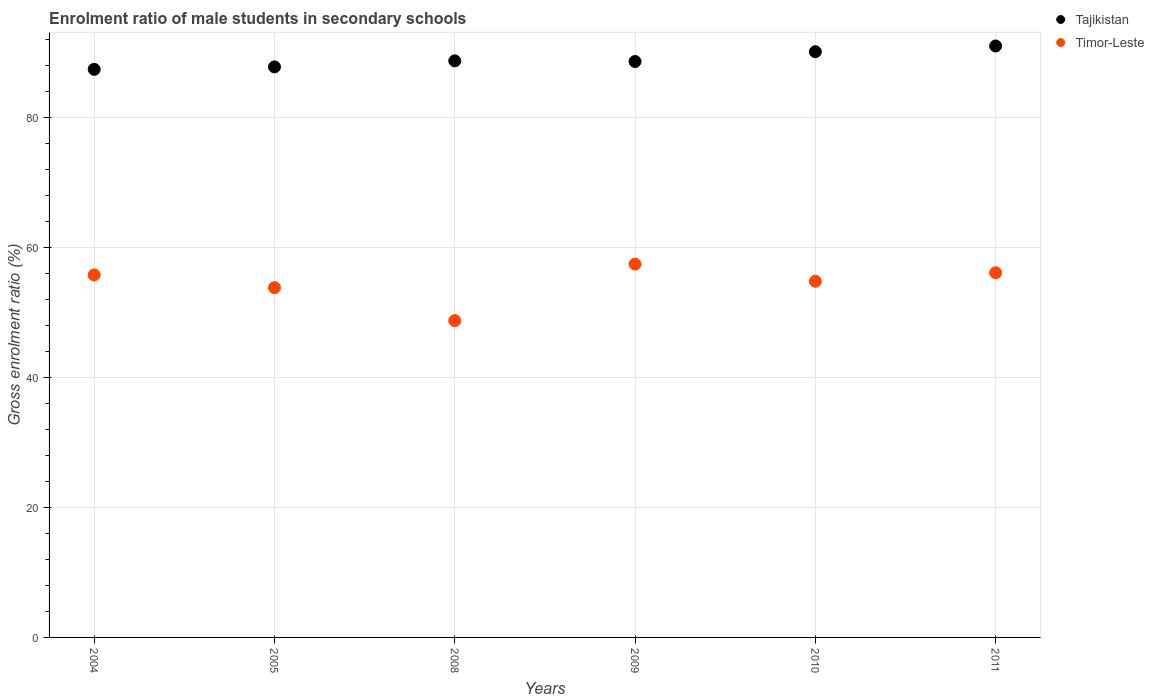What is the enrolment ratio of male students in secondary schools in Tajikistan in 2005?
Provide a succinct answer. 87.74. Across all years, what is the maximum enrolment ratio of male students in secondary schools in Tajikistan?
Offer a terse response. 90.96. Across all years, what is the minimum enrolment ratio of male students in secondary schools in Tajikistan?
Make the answer very short. 87.37. What is the total enrolment ratio of male students in secondary schools in Timor-Leste in the graph?
Give a very brief answer. 326.54. What is the difference between the enrolment ratio of male students in secondary schools in Timor-Leste in 2005 and that in 2009?
Ensure brevity in your answer.  -3.62. What is the difference between the enrolment ratio of male students in secondary schools in Timor-Leste in 2004 and the enrolment ratio of male students in secondary schools in Tajikistan in 2010?
Your answer should be compact. -34.32. What is the average enrolment ratio of male students in secondary schools in Timor-Leste per year?
Provide a succinct answer. 54.42. In the year 2009, what is the difference between the enrolment ratio of male students in secondary schools in Timor-Leste and enrolment ratio of male students in secondary schools in Tajikistan?
Offer a terse response. -31.16. In how many years, is the enrolment ratio of male students in secondary schools in Timor-Leste greater than 84 %?
Give a very brief answer. 0. What is the ratio of the enrolment ratio of male students in secondary schools in Tajikistan in 2005 to that in 2011?
Your answer should be compact. 0.96. What is the difference between the highest and the second highest enrolment ratio of male students in secondary schools in Timor-Leste?
Offer a terse response. 1.33. What is the difference between the highest and the lowest enrolment ratio of male students in secondary schools in Timor-Leste?
Give a very brief answer. 8.69. Is the sum of the enrolment ratio of male students in secondary schools in Tajikistan in 2010 and 2011 greater than the maximum enrolment ratio of male students in secondary schools in Timor-Leste across all years?
Offer a terse response. Yes. Is the enrolment ratio of male students in secondary schools in Tajikistan strictly less than the enrolment ratio of male students in secondary schools in Timor-Leste over the years?
Give a very brief answer. No. How many years are there in the graph?
Make the answer very short. 6. What is the difference between two consecutive major ticks on the Y-axis?
Your response must be concise. 20. Does the graph contain grids?
Offer a terse response. Yes. Where does the legend appear in the graph?
Your response must be concise. Top right. How many legend labels are there?
Offer a terse response. 2. How are the legend labels stacked?
Provide a short and direct response. Vertical. What is the title of the graph?
Make the answer very short. Enrolment ratio of male students in secondary schools. What is the Gross enrolment ratio (%) in Tajikistan in 2004?
Ensure brevity in your answer.  87.37. What is the Gross enrolment ratio (%) of Timor-Leste in 2004?
Give a very brief answer. 55.75. What is the Gross enrolment ratio (%) of Tajikistan in 2005?
Offer a terse response. 87.74. What is the Gross enrolment ratio (%) in Timor-Leste in 2005?
Ensure brevity in your answer.  53.79. What is the Gross enrolment ratio (%) in Tajikistan in 2008?
Provide a short and direct response. 88.67. What is the Gross enrolment ratio (%) in Timor-Leste in 2008?
Your response must be concise. 48.73. What is the Gross enrolment ratio (%) in Tajikistan in 2009?
Your answer should be compact. 88.57. What is the Gross enrolment ratio (%) in Timor-Leste in 2009?
Make the answer very short. 57.41. What is the Gross enrolment ratio (%) in Tajikistan in 2010?
Provide a succinct answer. 90.08. What is the Gross enrolment ratio (%) in Timor-Leste in 2010?
Offer a terse response. 54.77. What is the Gross enrolment ratio (%) of Tajikistan in 2011?
Your answer should be compact. 90.96. What is the Gross enrolment ratio (%) in Timor-Leste in 2011?
Your answer should be compact. 56.08. Across all years, what is the maximum Gross enrolment ratio (%) of Tajikistan?
Provide a succinct answer. 90.96. Across all years, what is the maximum Gross enrolment ratio (%) of Timor-Leste?
Your answer should be very brief. 57.41. Across all years, what is the minimum Gross enrolment ratio (%) of Tajikistan?
Your answer should be compact. 87.37. Across all years, what is the minimum Gross enrolment ratio (%) of Timor-Leste?
Ensure brevity in your answer.  48.73. What is the total Gross enrolment ratio (%) of Tajikistan in the graph?
Your answer should be very brief. 533.39. What is the total Gross enrolment ratio (%) in Timor-Leste in the graph?
Your response must be concise. 326.54. What is the difference between the Gross enrolment ratio (%) in Tajikistan in 2004 and that in 2005?
Make the answer very short. -0.38. What is the difference between the Gross enrolment ratio (%) of Timor-Leste in 2004 and that in 2005?
Your answer should be compact. 1.96. What is the difference between the Gross enrolment ratio (%) of Tajikistan in 2004 and that in 2008?
Give a very brief answer. -1.3. What is the difference between the Gross enrolment ratio (%) in Timor-Leste in 2004 and that in 2008?
Offer a terse response. 7.03. What is the difference between the Gross enrolment ratio (%) of Tajikistan in 2004 and that in 2009?
Offer a terse response. -1.2. What is the difference between the Gross enrolment ratio (%) in Timor-Leste in 2004 and that in 2009?
Offer a terse response. -1.66. What is the difference between the Gross enrolment ratio (%) in Tajikistan in 2004 and that in 2010?
Your response must be concise. -2.71. What is the difference between the Gross enrolment ratio (%) in Timor-Leste in 2004 and that in 2010?
Your answer should be very brief. 0.98. What is the difference between the Gross enrolment ratio (%) of Tajikistan in 2004 and that in 2011?
Provide a short and direct response. -3.59. What is the difference between the Gross enrolment ratio (%) in Timor-Leste in 2004 and that in 2011?
Offer a very short reply. -0.33. What is the difference between the Gross enrolment ratio (%) in Tajikistan in 2005 and that in 2008?
Give a very brief answer. -0.93. What is the difference between the Gross enrolment ratio (%) in Timor-Leste in 2005 and that in 2008?
Your response must be concise. 5.07. What is the difference between the Gross enrolment ratio (%) of Tajikistan in 2005 and that in 2009?
Provide a succinct answer. -0.83. What is the difference between the Gross enrolment ratio (%) of Timor-Leste in 2005 and that in 2009?
Ensure brevity in your answer.  -3.62. What is the difference between the Gross enrolment ratio (%) in Tajikistan in 2005 and that in 2010?
Provide a short and direct response. -2.34. What is the difference between the Gross enrolment ratio (%) of Timor-Leste in 2005 and that in 2010?
Keep it short and to the point. -0.98. What is the difference between the Gross enrolment ratio (%) of Tajikistan in 2005 and that in 2011?
Provide a short and direct response. -3.22. What is the difference between the Gross enrolment ratio (%) in Timor-Leste in 2005 and that in 2011?
Offer a terse response. -2.29. What is the difference between the Gross enrolment ratio (%) in Tajikistan in 2008 and that in 2009?
Ensure brevity in your answer.  0.1. What is the difference between the Gross enrolment ratio (%) in Timor-Leste in 2008 and that in 2009?
Your answer should be compact. -8.69. What is the difference between the Gross enrolment ratio (%) of Tajikistan in 2008 and that in 2010?
Offer a terse response. -1.41. What is the difference between the Gross enrolment ratio (%) of Timor-Leste in 2008 and that in 2010?
Keep it short and to the point. -6.05. What is the difference between the Gross enrolment ratio (%) in Tajikistan in 2008 and that in 2011?
Your answer should be very brief. -2.29. What is the difference between the Gross enrolment ratio (%) in Timor-Leste in 2008 and that in 2011?
Your response must be concise. -7.36. What is the difference between the Gross enrolment ratio (%) in Tajikistan in 2009 and that in 2010?
Your answer should be very brief. -1.51. What is the difference between the Gross enrolment ratio (%) in Timor-Leste in 2009 and that in 2010?
Your answer should be very brief. 2.64. What is the difference between the Gross enrolment ratio (%) in Tajikistan in 2009 and that in 2011?
Your answer should be compact. -2.39. What is the difference between the Gross enrolment ratio (%) of Timor-Leste in 2009 and that in 2011?
Offer a terse response. 1.33. What is the difference between the Gross enrolment ratio (%) in Tajikistan in 2010 and that in 2011?
Ensure brevity in your answer.  -0.88. What is the difference between the Gross enrolment ratio (%) in Timor-Leste in 2010 and that in 2011?
Provide a succinct answer. -1.31. What is the difference between the Gross enrolment ratio (%) in Tajikistan in 2004 and the Gross enrolment ratio (%) in Timor-Leste in 2005?
Make the answer very short. 33.58. What is the difference between the Gross enrolment ratio (%) of Tajikistan in 2004 and the Gross enrolment ratio (%) of Timor-Leste in 2008?
Give a very brief answer. 38.64. What is the difference between the Gross enrolment ratio (%) in Tajikistan in 2004 and the Gross enrolment ratio (%) in Timor-Leste in 2009?
Your response must be concise. 29.95. What is the difference between the Gross enrolment ratio (%) of Tajikistan in 2004 and the Gross enrolment ratio (%) of Timor-Leste in 2010?
Your answer should be very brief. 32.59. What is the difference between the Gross enrolment ratio (%) in Tajikistan in 2004 and the Gross enrolment ratio (%) in Timor-Leste in 2011?
Provide a short and direct response. 31.29. What is the difference between the Gross enrolment ratio (%) of Tajikistan in 2005 and the Gross enrolment ratio (%) of Timor-Leste in 2008?
Keep it short and to the point. 39.02. What is the difference between the Gross enrolment ratio (%) in Tajikistan in 2005 and the Gross enrolment ratio (%) in Timor-Leste in 2009?
Offer a terse response. 30.33. What is the difference between the Gross enrolment ratio (%) of Tajikistan in 2005 and the Gross enrolment ratio (%) of Timor-Leste in 2010?
Give a very brief answer. 32.97. What is the difference between the Gross enrolment ratio (%) of Tajikistan in 2005 and the Gross enrolment ratio (%) of Timor-Leste in 2011?
Your response must be concise. 31.66. What is the difference between the Gross enrolment ratio (%) in Tajikistan in 2008 and the Gross enrolment ratio (%) in Timor-Leste in 2009?
Your answer should be compact. 31.26. What is the difference between the Gross enrolment ratio (%) of Tajikistan in 2008 and the Gross enrolment ratio (%) of Timor-Leste in 2010?
Give a very brief answer. 33.9. What is the difference between the Gross enrolment ratio (%) of Tajikistan in 2008 and the Gross enrolment ratio (%) of Timor-Leste in 2011?
Give a very brief answer. 32.59. What is the difference between the Gross enrolment ratio (%) in Tajikistan in 2009 and the Gross enrolment ratio (%) in Timor-Leste in 2010?
Offer a terse response. 33.8. What is the difference between the Gross enrolment ratio (%) of Tajikistan in 2009 and the Gross enrolment ratio (%) of Timor-Leste in 2011?
Keep it short and to the point. 32.49. What is the difference between the Gross enrolment ratio (%) in Tajikistan in 2010 and the Gross enrolment ratio (%) in Timor-Leste in 2011?
Your answer should be very brief. 34. What is the average Gross enrolment ratio (%) of Tajikistan per year?
Your response must be concise. 88.9. What is the average Gross enrolment ratio (%) in Timor-Leste per year?
Your answer should be very brief. 54.42. In the year 2004, what is the difference between the Gross enrolment ratio (%) in Tajikistan and Gross enrolment ratio (%) in Timor-Leste?
Offer a very short reply. 31.61. In the year 2005, what is the difference between the Gross enrolment ratio (%) in Tajikistan and Gross enrolment ratio (%) in Timor-Leste?
Your answer should be compact. 33.95. In the year 2008, what is the difference between the Gross enrolment ratio (%) of Tajikistan and Gross enrolment ratio (%) of Timor-Leste?
Your answer should be very brief. 39.95. In the year 2009, what is the difference between the Gross enrolment ratio (%) in Tajikistan and Gross enrolment ratio (%) in Timor-Leste?
Offer a very short reply. 31.16. In the year 2010, what is the difference between the Gross enrolment ratio (%) in Tajikistan and Gross enrolment ratio (%) in Timor-Leste?
Make the answer very short. 35.3. In the year 2011, what is the difference between the Gross enrolment ratio (%) of Tajikistan and Gross enrolment ratio (%) of Timor-Leste?
Provide a succinct answer. 34.88. What is the ratio of the Gross enrolment ratio (%) in Timor-Leste in 2004 to that in 2005?
Your answer should be very brief. 1.04. What is the ratio of the Gross enrolment ratio (%) in Timor-Leste in 2004 to that in 2008?
Provide a short and direct response. 1.14. What is the ratio of the Gross enrolment ratio (%) in Tajikistan in 2004 to that in 2009?
Keep it short and to the point. 0.99. What is the ratio of the Gross enrolment ratio (%) in Timor-Leste in 2004 to that in 2009?
Make the answer very short. 0.97. What is the ratio of the Gross enrolment ratio (%) of Tajikistan in 2004 to that in 2010?
Keep it short and to the point. 0.97. What is the ratio of the Gross enrolment ratio (%) in Timor-Leste in 2004 to that in 2010?
Offer a very short reply. 1.02. What is the ratio of the Gross enrolment ratio (%) in Tajikistan in 2004 to that in 2011?
Make the answer very short. 0.96. What is the ratio of the Gross enrolment ratio (%) of Timor-Leste in 2005 to that in 2008?
Your response must be concise. 1.1. What is the ratio of the Gross enrolment ratio (%) of Timor-Leste in 2005 to that in 2009?
Make the answer very short. 0.94. What is the ratio of the Gross enrolment ratio (%) of Tajikistan in 2005 to that in 2010?
Give a very brief answer. 0.97. What is the ratio of the Gross enrolment ratio (%) in Timor-Leste in 2005 to that in 2010?
Ensure brevity in your answer.  0.98. What is the ratio of the Gross enrolment ratio (%) of Tajikistan in 2005 to that in 2011?
Offer a terse response. 0.96. What is the ratio of the Gross enrolment ratio (%) of Timor-Leste in 2005 to that in 2011?
Your answer should be very brief. 0.96. What is the ratio of the Gross enrolment ratio (%) in Tajikistan in 2008 to that in 2009?
Give a very brief answer. 1. What is the ratio of the Gross enrolment ratio (%) in Timor-Leste in 2008 to that in 2009?
Give a very brief answer. 0.85. What is the ratio of the Gross enrolment ratio (%) of Tajikistan in 2008 to that in 2010?
Provide a succinct answer. 0.98. What is the ratio of the Gross enrolment ratio (%) in Timor-Leste in 2008 to that in 2010?
Provide a short and direct response. 0.89. What is the ratio of the Gross enrolment ratio (%) of Tajikistan in 2008 to that in 2011?
Offer a terse response. 0.97. What is the ratio of the Gross enrolment ratio (%) of Timor-Leste in 2008 to that in 2011?
Your response must be concise. 0.87. What is the ratio of the Gross enrolment ratio (%) in Tajikistan in 2009 to that in 2010?
Keep it short and to the point. 0.98. What is the ratio of the Gross enrolment ratio (%) in Timor-Leste in 2009 to that in 2010?
Your response must be concise. 1.05. What is the ratio of the Gross enrolment ratio (%) of Tajikistan in 2009 to that in 2011?
Ensure brevity in your answer.  0.97. What is the ratio of the Gross enrolment ratio (%) of Timor-Leste in 2009 to that in 2011?
Provide a succinct answer. 1.02. What is the ratio of the Gross enrolment ratio (%) in Tajikistan in 2010 to that in 2011?
Give a very brief answer. 0.99. What is the ratio of the Gross enrolment ratio (%) of Timor-Leste in 2010 to that in 2011?
Provide a succinct answer. 0.98. What is the difference between the highest and the second highest Gross enrolment ratio (%) in Tajikistan?
Ensure brevity in your answer.  0.88. What is the difference between the highest and the second highest Gross enrolment ratio (%) in Timor-Leste?
Offer a very short reply. 1.33. What is the difference between the highest and the lowest Gross enrolment ratio (%) in Tajikistan?
Offer a terse response. 3.59. What is the difference between the highest and the lowest Gross enrolment ratio (%) in Timor-Leste?
Ensure brevity in your answer.  8.69. 